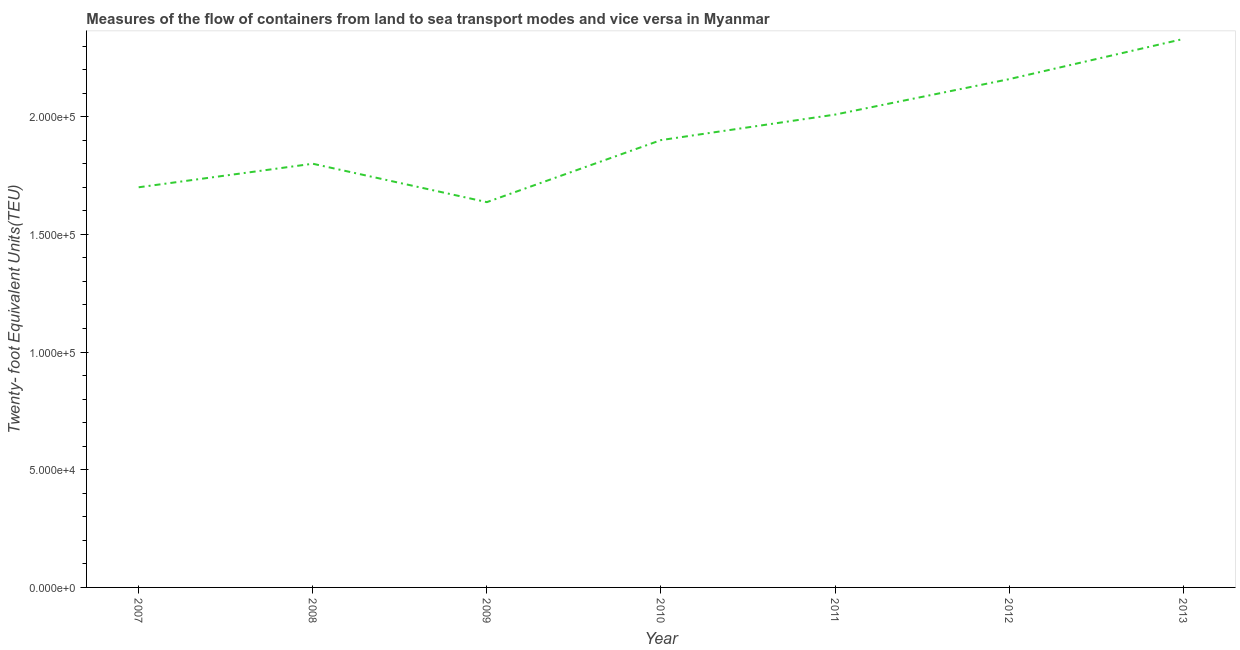What is the container port traffic in 2007?
Your answer should be compact. 1.70e+05. Across all years, what is the maximum container port traffic?
Offer a terse response. 2.33e+05. Across all years, what is the minimum container port traffic?
Provide a short and direct response. 1.64e+05. In which year was the container port traffic maximum?
Offer a very short reply. 2013. In which year was the container port traffic minimum?
Offer a terse response. 2009. What is the sum of the container port traffic?
Provide a short and direct response. 1.35e+06. What is the difference between the container port traffic in 2007 and 2008?
Your response must be concise. -10000. What is the average container port traffic per year?
Offer a terse response. 1.93e+05. What is the median container port traffic?
Make the answer very short. 1.90e+05. What is the ratio of the container port traffic in 2011 to that in 2012?
Provide a succinct answer. 0.93. Is the container port traffic in 2007 less than that in 2012?
Offer a very short reply. Yes. Is the difference between the container port traffic in 2007 and 2012 greater than the difference between any two years?
Give a very brief answer. No. What is the difference between the highest and the second highest container port traffic?
Your answer should be compact. 1.71e+04. Is the sum of the container port traffic in 2011 and 2012 greater than the maximum container port traffic across all years?
Keep it short and to the point. Yes. What is the difference between the highest and the lowest container port traffic?
Provide a succinct answer. 6.93e+04. Does the container port traffic monotonically increase over the years?
Your answer should be very brief. No. How many lines are there?
Your response must be concise. 1. How many years are there in the graph?
Keep it short and to the point. 7. Are the values on the major ticks of Y-axis written in scientific E-notation?
Ensure brevity in your answer.  Yes. Does the graph contain any zero values?
Make the answer very short. No. What is the title of the graph?
Provide a short and direct response. Measures of the flow of containers from land to sea transport modes and vice versa in Myanmar. What is the label or title of the X-axis?
Provide a short and direct response. Year. What is the label or title of the Y-axis?
Offer a very short reply. Twenty- foot Equivalent Units(TEU). What is the Twenty- foot Equivalent Units(TEU) in 2008?
Your response must be concise. 1.80e+05. What is the Twenty- foot Equivalent Units(TEU) in 2009?
Ensure brevity in your answer.  1.64e+05. What is the Twenty- foot Equivalent Units(TEU) in 2010?
Provide a succinct answer. 1.90e+05. What is the Twenty- foot Equivalent Units(TEU) in 2011?
Your answer should be compact. 2.01e+05. What is the Twenty- foot Equivalent Units(TEU) of 2012?
Provide a short and direct response. 2.16e+05. What is the Twenty- foot Equivalent Units(TEU) of 2013?
Your answer should be compact. 2.33e+05. What is the difference between the Twenty- foot Equivalent Units(TEU) in 2007 and 2008?
Give a very brief answer. -10000. What is the difference between the Twenty- foot Equivalent Units(TEU) in 2007 and 2009?
Make the answer very short. 6308. What is the difference between the Twenty- foot Equivalent Units(TEU) in 2007 and 2010?
Keep it short and to the point. -2.00e+04. What is the difference between the Twenty- foot Equivalent Units(TEU) in 2007 and 2011?
Keep it short and to the point. -3.09e+04. What is the difference between the Twenty- foot Equivalent Units(TEU) in 2007 and 2012?
Make the answer very short. -4.59e+04. What is the difference between the Twenty- foot Equivalent Units(TEU) in 2007 and 2013?
Your answer should be compact. -6.30e+04. What is the difference between the Twenty- foot Equivalent Units(TEU) in 2008 and 2009?
Offer a very short reply. 1.63e+04. What is the difference between the Twenty- foot Equivalent Units(TEU) in 2008 and 2010?
Provide a succinct answer. -1.00e+04. What is the difference between the Twenty- foot Equivalent Units(TEU) in 2008 and 2011?
Offer a terse response. -2.09e+04. What is the difference between the Twenty- foot Equivalent Units(TEU) in 2008 and 2012?
Provide a succinct answer. -3.59e+04. What is the difference between the Twenty- foot Equivalent Units(TEU) in 2008 and 2013?
Your answer should be compact. -5.30e+04. What is the difference between the Twenty- foot Equivalent Units(TEU) in 2009 and 2010?
Your answer should be compact. -2.64e+04. What is the difference between the Twenty- foot Equivalent Units(TEU) in 2009 and 2011?
Offer a very short reply. -3.72e+04. What is the difference between the Twenty- foot Equivalent Units(TEU) in 2009 and 2012?
Ensure brevity in your answer.  -5.23e+04. What is the difference between the Twenty- foot Equivalent Units(TEU) in 2009 and 2013?
Your answer should be compact. -6.93e+04. What is the difference between the Twenty- foot Equivalent Units(TEU) in 2010 and 2011?
Provide a succinct answer. -1.08e+04. What is the difference between the Twenty- foot Equivalent Units(TEU) in 2010 and 2012?
Make the answer very short. -2.59e+04. What is the difference between the Twenty- foot Equivalent Units(TEU) in 2010 and 2013?
Your answer should be very brief. -4.30e+04. What is the difference between the Twenty- foot Equivalent Units(TEU) in 2011 and 2012?
Keep it short and to the point. -1.51e+04. What is the difference between the Twenty- foot Equivalent Units(TEU) in 2011 and 2013?
Your response must be concise. -3.21e+04. What is the difference between the Twenty- foot Equivalent Units(TEU) in 2012 and 2013?
Offer a terse response. -1.71e+04. What is the ratio of the Twenty- foot Equivalent Units(TEU) in 2007 to that in 2008?
Your answer should be very brief. 0.94. What is the ratio of the Twenty- foot Equivalent Units(TEU) in 2007 to that in 2009?
Keep it short and to the point. 1.04. What is the ratio of the Twenty- foot Equivalent Units(TEU) in 2007 to that in 2010?
Make the answer very short. 0.9. What is the ratio of the Twenty- foot Equivalent Units(TEU) in 2007 to that in 2011?
Offer a terse response. 0.85. What is the ratio of the Twenty- foot Equivalent Units(TEU) in 2007 to that in 2012?
Your answer should be very brief. 0.79. What is the ratio of the Twenty- foot Equivalent Units(TEU) in 2007 to that in 2013?
Make the answer very short. 0.73. What is the ratio of the Twenty- foot Equivalent Units(TEU) in 2008 to that in 2009?
Offer a terse response. 1.1. What is the ratio of the Twenty- foot Equivalent Units(TEU) in 2008 to that in 2010?
Offer a very short reply. 0.95. What is the ratio of the Twenty- foot Equivalent Units(TEU) in 2008 to that in 2011?
Provide a succinct answer. 0.9. What is the ratio of the Twenty- foot Equivalent Units(TEU) in 2008 to that in 2012?
Keep it short and to the point. 0.83. What is the ratio of the Twenty- foot Equivalent Units(TEU) in 2008 to that in 2013?
Offer a terse response. 0.77. What is the ratio of the Twenty- foot Equivalent Units(TEU) in 2009 to that in 2010?
Offer a terse response. 0.86. What is the ratio of the Twenty- foot Equivalent Units(TEU) in 2009 to that in 2011?
Provide a succinct answer. 0.81. What is the ratio of the Twenty- foot Equivalent Units(TEU) in 2009 to that in 2012?
Ensure brevity in your answer.  0.76. What is the ratio of the Twenty- foot Equivalent Units(TEU) in 2009 to that in 2013?
Your response must be concise. 0.7. What is the ratio of the Twenty- foot Equivalent Units(TEU) in 2010 to that in 2011?
Provide a succinct answer. 0.95. What is the ratio of the Twenty- foot Equivalent Units(TEU) in 2010 to that in 2012?
Offer a very short reply. 0.88. What is the ratio of the Twenty- foot Equivalent Units(TEU) in 2010 to that in 2013?
Your response must be concise. 0.82. What is the ratio of the Twenty- foot Equivalent Units(TEU) in 2011 to that in 2012?
Your answer should be very brief. 0.93. What is the ratio of the Twenty- foot Equivalent Units(TEU) in 2011 to that in 2013?
Provide a succinct answer. 0.86. What is the ratio of the Twenty- foot Equivalent Units(TEU) in 2012 to that in 2013?
Offer a very short reply. 0.93. 